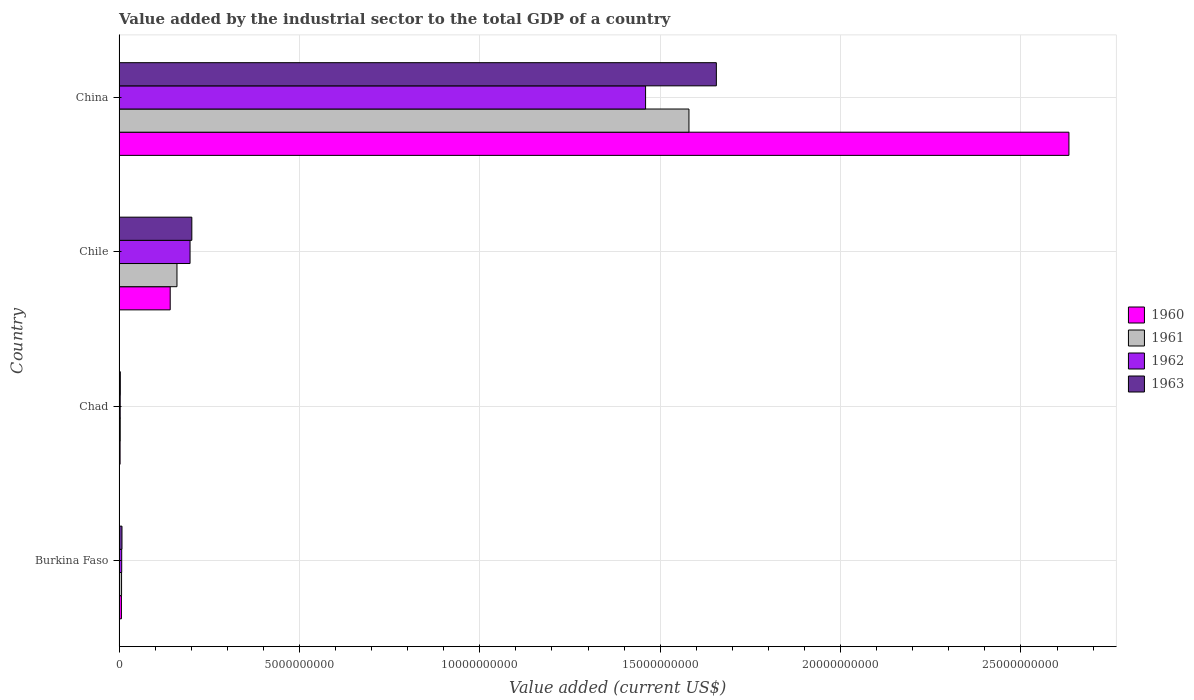How many groups of bars are there?
Your answer should be compact. 4. What is the label of the 3rd group of bars from the top?
Provide a short and direct response. Chad. What is the value added by the industrial sector to the total GDP in 1963 in Burkina Faso?
Keep it short and to the point. 8.13e+07. Across all countries, what is the maximum value added by the industrial sector to the total GDP in 1963?
Your answer should be compact. 1.66e+1. Across all countries, what is the minimum value added by the industrial sector to the total GDP in 1960?
Make the answer very short. 2.88e+07. In which country was the value added by the industrial sector to the total GDP in 1960 minimum?
Make the answer very short. Chad. What is the total value added by the industrial sector to the total GDP in 1961 in the graph?
Offer a very short reply. 1.75e+1. What is the difference between the value added by the industrial sector to the total GDP in 1963 in Chad and that in China?
Provide a short and direct response. -1.65e+1. What is the difference between the value added by the industrial sector to the total GDP in 1961 in Chile and the value added by the industrial sector to the total GDP in 1963 in China?
Your response must be concise. -1.50e+1. What is the average value added by the industrial sector to the total GDP in 1960 per country?
Keep it short and to the point. 6.96e+09. What is the difference between the value added by the industrial sector to the total GDP in 1961 and value added by the industrial sector to the total GDP in 1962 in China?
Provide a succinct answer. 1.20e+09. What is the ratio of the value added by the industrial sector to the total GDP in 1963 in Chile to that in China?
Your answer should be compact. 0.12. Is the value added by the industrial sector to the total GDP in 1960 in Chad less than that in China?
Give a very brief answer. Yes. What is the difference between the highest and the second highest value added by the industrial sector to the total GDP in 1961?
Offer a terse response. 1.42e+1. What is the difference between the highest and the lowest value added by the industrial sector to the total GDP in 1961?
Your response must be concise. 1.58e+1. Is it the case that in every country, the sum of the value added by the industrial sector to the total GDP in 1963 and value added by the industrial sector to the total GDP in 1961 is greater than the sum of value added by the industrial sector to the total GDP in 1960 and value added by the industrial sector to the total GDP in 1962?
Offer a very short reply. No. What does the 1st bar from the bottom in Burkina Faso represents?
Your answer should be compact. 1960. Is it the case that in every country, the sum of the value added by the industrial sector to the total GDP in 1962 and value added by the industrial sector to the total GDP in 1961 is greater than the value added by the industrial sector to the total GDP in 1960?
Offer a very short reply. Yes. How many bars are there?
Make the answer very short. 16. Are all the bars in the graph horizontal?
Provide a succinct answer. Yes. How many countries are there in the graph?
Make the answer very short. 4. What is the difference between two consecutive major ticks on the X-axis?
Your response must be concise. 5.00e+09. Are the values on the major ticks of X-axis written in scientific E-notation?
Offer a very short reply. No. Does the graph contain any zero values?
Your answer should be compact. No. Does the graph contain grids?
Provide a short and direct response. Yes. How many legend labels are there?
Offer a terse response. 4. What is the title of the graph?
Provide a short and direct response. Value added by the industrial sector to the total GDP of a country. What is the label or title of the X-axis?
Make the answer very short. Value added (current US$). What is the label or title of the Y-axis?
Ensure brevity in your answer.  Country. What is the Value added (current US$) of 1960 in Burkina Faso?
Provide a succinct answer. 6.58e+07. What is the Value added (current US$) in 1961 in Burkina Faso?
Your response must be concise. 6.97e+07. What is the Value added (current US$) of 1962 in Burkina Faso?
Your response must be concise. 7.35e+07. What is the Value added (current US$) in 1963 in Burkina Faso?
Provide a succinct answer. 8.13e+07. What is the Value added (current US$) of 1960 in Chad?
Offer a very short reply. 2.88e+07. What is the Value added (current US$) of 1961 in Chad?
Your answer should be compact. 3.27e+07. What is the Value added (current US$) in 1962 in Chad?
Offer a terse response. 3.17e+07. What is the Value added (current US$) in 1963 in Chad?
Your answer should be very brief. 3.49e+07. What is the Value added (current US$) in 1960 in Chile?
Keep it short and to the point. 1.42e+09. What is the Value added (current US$) in 1961 in Chile?
Ensure brevity in your answer.  1.61e+09. What is the Value added (current US$) in 1962 in Chile?
Give a very brief answer. 1.97e+09. What is the Value added (current US$) in 1963 in Chile?
Provide a succinct answer. 2.02e+09. What is the Value added (current US$) of 1960 in China?
Ensure brevity in your answer.  2.63e+1. What is the Value added (current US$) of 1961 in China?
Give a very brief answer. 1.58e+1. What is the Value added (current US$) of 1962 in China?
Ensure brevity in your answer.  1.46e+1. What is the Value added (current US$) of 1963 in China?
Your answer should be compact. 1.66e+1. Across all countries, what is the maximum Value added (current US$) of 1960?
Offer a terse response. 2.63e+1. Across all countries, what is the maximum Value added (current US$) in 1961?
Offer a very short reply. 1.58e+1. Across all countries, what is the maximum Value added (current US$) in 1962?
Give a very brief answer. 1.46e+1. Across all countries, what is the maximum Value added (current US$) of 1963?
Keep it short and to the point. 1.66e+1. Across all countries, what is the minimum Value added (current US$) in 1960?
Offer a terse response. 2.88e+07. Across all countries, what is the minimum Value added (current US$) in 1961?
Ensure brevity in your answer.  3.27e+07. Across all countries, what is the minimum Value added (current US$) of 1962?
Provide a succinct answer. 3.17e+07. Across all countries, what is the minimum Value added (current US$) in 1963?
Make the answer very short. 3.49e+07. What is the total Value added (current US$) in 1960 in the graph?
Offer a very short reply. 2.78e+1. What is the total Value added (current US$) in 1961 in the graph?
Offer a very short reply. 1.75e+1. What is the total Value added (current US$) in 1962 in the graph?
Make the answer very short. 1.67e+1. What is the total Value added (current US$) of 1963 in the graph?
Your answer should be very brief. 1.87e+1. What is the difference between the Value added (current US$) of 1960 in Burkina Faso and that in Chad?
Provide a succinct answer. 3.70e+07. What is the difference between the Value added (current US$) in 1961 in Burkina Faso and that in Chad?
Make the answer very short. 3.70e+07. What is the difference between the Value added (current US$) in 1962 in Burkina Faso and that in Chad?
Give a very brief answer. 4.18e+07. What is the difference between the Value added (current US$) of 1963 in Burkina Faso and that in Chad?
Give a very brief answer. 4.64e+07. What is the difference between the Value added (current US$) of 1960 in Burkina Faso and that in Chile?
Offer a terse response. -1.35e+09. What is the difference between the Value added (current US$) of 1961 in Burkina Faso and that in Chile?
Provide a succinct answer. -1.54e+09. What is the difference between the Value added (current US$) in 1962 in Burkina Faso and that in Chile?
Provide a short and direct response. -1.89e+09. What is the difference between the Value added (current US$) of 1963 in Burkina Faso and that in Chile?
Give a very brief answer. -1.94e+09. What is the difference between the Value added (current US$) of 1960 in Burkina Faso and that in China?
Keep it short and to the point. -2.63e+1. What is the difference between the Value added (current US$) in 1961 in Burkina Faso and that in China?
Your response must be concise. -1.57e+1. What is the difference between the Value added (current US$) of 1962 in Burkina Faso and that in China?
Provide a succinct answer. -1.45e+1. What is the difference between the Value added (current US$) of 1963 in Burkina Faso and that in China?
Keep it short and to the point. -1.65e+1. What is the difference between the Value added (current US$) in 1960 in Chad and that in Chile?
Provide a short and direct response. -1.39e+09. What is the difference between the Value added (current US$) of 1961 in Chad and that in Chile?
Provide a short and direct response. -1.57e+09. What is the difference between the Value added (current US$) of 1962 in Chad and that in Chile?
Keep it short and to the point. -1.94e+09. What is the difference between the Value added (current US$) in 1963 in Chad and that in Chile?
Give a very brief answer. -1.98e+09. What is the difference between the Value added (current US$) in 1960 in Chad and that in China?
Provide a succinct answer. -2.63e+1. What is the difference between the Value added (current US$) of 1961 in Chad and that in China?
Keep it short and to the point. -1.58e+1. What is the difference between the Value added (current US$) in 1962 in Chad and that in China?
Offer a very short reply. -1.46e+1. What is the difference between the Value added (current US$) in 1963 in Chad and that in China?
Keep it short and to the point. -1.65e+1. What is the difference between the Value added (current US$) in 1960 in Chile and that in China?
Your answer should be very brief. -2.49e+1. What is the difference between the Value added (current US$) of 1961 in Chile and that in China?
Give a very brief answer. -1.42e+1. What is the difference between the Value added (current US$) in 1962 in Chile and that in China?
Keep it short and to the point. -1.26e+1. What is the difference between the Value added (current US$) in 1963 in Chile and that in China?
Offer a terse response. -1.45e+1. What is the difference between the Value added (current US$) of 1960 in Burkina Faso and the Value added (current US$) of 1961 in Chad?
Make the answer very short. 3.32e+07. What is the difference between the Value added (current US$) in 1960 in Burkina Faso and the Value added (current US$) in 1962 in Chad?
Ensure brevity in your answer.  3.41e+07. What is the difference between the Value added (current US$) of 1960 in Burkina Faso and the Value added (current US$) of 1963 in Chad?
Your answer should be compact. 3.09e+07. What is the difference between the Value added (current US$) in 1961 in Burkina Faso and the Value added (current US$) in 1962 in Chad?
Provide a succinct answer. 3.79e+07. What is the difference between the Value added (current US$) of 1961 in Burkina Faso and the Value added (current US$) of 1963 in Chad?
Keep it short and to the point. 3.48e+07. What is the difference between the Value added (current US$) of 1962 in Burkina Faso and the Value added (current US$) of 1963 in Chad?
Offer a very short reply. 3.86e+07. What is the difference between the Value added (current US$) of 1960 in Burkina Faso and the Value added (current US$) of 1961 in Chile?
Ensure brevity in your answer.  -1.54e+09. What is the difference between the Value added (current US$) of 1960 in Burkina Faso and the Value added (current US$) of 1962 in Chile?
Make the answer very short. -1.90e+09. What is the difference between the Value added (current US$) of 1960 in Burkina Faso and the Value added (current US$) of 1963 in Chile?
Ensure brevity in your answer.  -1.95e+09. What is the difference between the Value added (current US$) of 1961 in Burkina Faso and the Value added (current US$) of 1962 in Chile?
Ensure brevity in your answer.  -1.90e+09. What is the difference between the Value added (current US$) in 1961 in Burkina Faso and the Value added (current US$) in 1963 in Chile?
Provide a short and direct response. -1.95e+09. What is the difference between the Value added (current US$) of 1962 in Burkina Faso and the Value added (current US$) of 1963 in Chile?
Offer a very short reply. -1.94e+09. What is the difference between the Value added (current US$) of 1960 in Burkina Faso and the Value added (current US$) of 1961 in China?
Provide a succinct answer. -1.57e+1. What is the difference between the Value added (current US$) of 1960 in Burkina Faso and the Value added (current US$) of 1962 in China?
Ensure brevity in your answer.  -1.45e+1. What is the difference between the Value added (current US$) in 1960 in Burkina Faso and the Value added (current US$) in 1963 in China?
Offer a very short reply. -1.65e+1. What is the difference between the Value added (current US$) of 1961 in Burkina Faso and the Value added (current US$) of 1962 in China?
Keep it short and to the point. -1.45e+1. What is the difference between the Value added (current US$) in 1961 in Burkina Faso and the Value added (current US$) in 1963 in China?
Give a very brief answer. -1.65e+1. What is the difference between the Value added (current US$) in 1962 in Burkina Faso and the Value added (current US$) in 1963 in China?
Offer a very short reply. -1.65e+1. What is the difference between the Value added (current US$) of 1960 in Chad and the Value added (current US$) of 1961 in Chile?
Ensure brevity in your answer.  -1.58e+09. What is the difference between the Value added (current US$) in 1960 in Chad and the Value added (current US$) in 1962 in Chile?
Ensure brevity in your answer.  -1.94e+09. What is the difference between the Value added (current US$) in 1960 in Chad and the Value added (current US$) in 1963 in Chile?
Offer a very short reply. -1.99e+09. What is the difference between the Value added (current US$) in 1961 in Chad and the Value added (current US$) in 1962 in Chile?
Offer a terse response. -1.94e+09. What is the difference between the Value added (current US$) of 1961 in Chad and the Value added (current US$) of 1963 in Chile?
Your answer should be very brief. -1.98e+09. What is the difference between the Value added (current US$) of 1962 in Chad and the Value added (current US$) of 1963 in Chile?
Give a very brief answer. -1.99e+09. What is the difference between the Value added (current US$) of 1960 in Chad and the Value added (current US$) of 1961 in China?
Your answer should be very brief. -1.58e+1. What is the difference between the Value added (current US$) in 1960 in Chad and the Value added (current US$) in 1962 in China?
Your response must be concise. -1.46e+1. What is the difference between the Value added (current US$) of 1960 in Chad and the Value added (current US$) of 1963 in China?
Offer a very short reply. -1.65e+1. What is the difference between the Value added (current US$) in 1961 in Chad and the Value added (current US$) in 1962 in China?
Offer a very short reply. -1.46e+1. What is the difference between the Value added (current US$) of 1961 in Chad and the Value added (current US$) of 1963 in China?
Give a very brief answer. -1.65e+1. What is the difference between the Value added (current US$) of 1962 in Chad and the Value added (current US$) of 1963 in China?
Your answer should be compact. -1.65e+1. What is the difference between the Value added (current US$) in 1960 in Chile and the Value added (current US$) in 1961 in China?
Your answer should be compact. -1.44e+1. What is the difference between the Value added (current US$) of 1960 in Chile and the Value added (current US$) of 1962 in China?
Give a very brief answer. -1.32e+1. What is the difference between the Value added (current US$) in 1960 in Chile and the Value added (current US$) in 1963 in China?
Your answer should be compact. -1.51e+1. What is the difference between the Value added (current US$) of 1961 in Chile and the Value added (current US$) of 1962 in China?
Keep it short and to the point. -1.30e+1. What is the difference between the Value added (current US$) in 1961 in Chile and the Value added (current US$) in 1963 in China?
Give a very brief answer. -1.50e+1. What is the difference between the Value added (current US$) in 1962 in Chile and the Value added (current US$) in 1963 in China?
Give a very brief answer. -1.46e+1. What is the average Value added (current US$) of 1960 per country?
Your answer should be compact. 6.96e+09. What is the average Value added (current US$) in 1961 per country?
Provide a short and direct response. 4.38e+09. What is the average Value added (current US$) in 1962 per country?
Your answer should be very brief. 4.17e+09. What is the average Value added (current US$) of 1963 per country?
Offer a very short reply. 4.67e+09. What is the difference between the Value added (current US$) of 1960 and Value added (current US$) of 1961 in Burkina Faso?
Offer a terse response. -3.88e+06. What is the difference between the Value added (current US$) in 1960 and Value added (current US$) in 1962 in Burkina Faso?
Make the answer very short. -7.71e+06. What is the difference between the Value added (current US$) in 1960 and Value added (current US$) in 1963 in Burkina Faso?
Your response must be concise. -1.55e+07. What is the difference between the Value added (current US$) of 1961 and Value added (current US$) of 1962 in Burkina Faso?
Ensure brevity in your answer.  -3.83e+06. What is the difference between the Value added (current US$) of 1961 and Value added (current US$) of 1963 in Burkina Faso?
Make the answer very short. -1.16e+07. What is the difference between the Value added (current US$) of 1962 and Value added (current US$) of 1963 in Burkina Faso?
Provide a succinct answer. -7.75e+06. What is the difference between the Value added (current US$) in 1960 and Value added (current US$) in 1961 in Chad?
Your answer should be very brief. -3.82e+06. What is the difference between the Value added (current US$) in 1960 and Value added (current US$) in 1962 in Chad?
Keep it short and to the point. -2.90e+06. What is the difference between the Value added (current US$) in 1960 and Value added (current US$) in 1963 in Chad?
Provide a short and direct response. -6.04e+06. What is the difference between the Value added (current US$) in 1961 and Value added (current US$) in 1962 in Chad?
Make the answer very short. 9.19e+05. What is the difference between the Value added (current US$) in 1961 and Value added (current US$) in 1963 in Chad?
Offer a very short reply. -2.22e+06. What is the difference between the Value added (current US$) of 1962 and Value added (current US$) of 1963 in Chad?
Keep it short and to the point. -3.14e+06. What is the difference between the Value added (current US$) in 1960 and Value added (current US$) in 1961 in Chile?
Give a very brief answer. -1.88e+08. What is the difference between the Value added (current US$) in 1960 and Value added (current US$) in 1962 in Chile?
Ensure brevity in your answer.  -5.50e+08. What is the difference between the Value added (current US$) of 1960 and Value added (current US$) of 1963 in Chile?
Your answer should be very brief. -5.99e+08. What is the difference between the Value added (current US$) of 1961 and Value added (current US$) of 1962 in Chile?
Give a very brief answer. -3.63e+08. What is the difference between the Value added (current US$) of 1961 and Value added (current US$) of 1963 in Chile?
Offer a terse response. -4.12e+08. What is the difference between the Value added (current US$) in 1962 and Value added (current US$) in 1963 in Chile?
Give a very brief answer. -4.92e+07. What is the difference between the Value added (current US$) in 1960 and Value added (current US$) in 1961 in China?
Provide a short and direct response. 1.05e+1. What is the difference between the Value added (current US$) of 1960 and Value added (current US$) of 1962 in China?
Your response must be concise. 1.17e+1. What is the difference between the Value added (current US$) of 1960 and Value added (current US$) of 1963 in China?
Your response must be concise. 9.77e+09. What is the difference between the Value added (current US$) of 1961 and Value added (current US$) of 1962 in China?
Ensure brevity in your answer.  1.20e+09. What is the difference between the Value added (current US$) of 1961 and Value added (current US$) of 1963 in China?
Your answer should be compact. -7.60e+08. What is the difference between the Value added (current US$) of 1962 and Value added (current US$) of 1963 in China?
Give a very brief answer. -1.96e+09. What is the ratio of the Value added (current US$) in 1960 in Burkina Faso to that in Chad?
Your answer should be compact. 2.28. What is the ratio of the Value added (current US$) in 1961 in Burkina Faso to that in Chad?
Keep it short and to the point. 2.13. What is the ratio of the Value added (current US$) of 1962 in Burkina Faso to that in Chad?
Your answer should be very brief. 2.32. What is the ratio of the Value added (current US$) in 1963 in Burkina Faso to that in Chad?
Keep it short and to the point. 2.33. What is the ratio of the Value added (current US$) of 1960 in Burkina Faso to that in Chile?
Provide a short and direct response. 0.05. What is the ratio of the Value added (current US$) in 1961 in Burkina Faso to that in Chile?
Offer a terse response. 0.04. What is the ratio of the Value added (current US$) in 1962 in Burkina Faso to that in Chile?
Give a very brief answer. 0.04. What is the ratio of the Value added (current US$) in 1963 in Burkina Faso to that in Chile?
Your response must be concise. 0.04. What is the ratio of the Value added (current US$) of 1960 in Burkina Faso to that in China?
Offer a terse response. 0. What is the ratio of the Value added (current US$) in 1961 in Burkina Faso to that in China?
Offer a terse response. 0. What is the ratio of the Value added (current US$) in 1962 in Burkina Faso to that in China?
Offer a terse response. 0.01. What is the ratio of the Value added (current US$) in 1963 in Burkina Faso to that in China?
Keep it short and to the point. 0. What is the ratio of the Value added (current US$) of 1960 in Chad to that in Chile?
Ensure brevity in your answer.  0.02. What is the ratio of the Value added (current US$) of 1961 in Chad to that in Chile?
Your response must be concise. 0.02. What is the ratio of the Value added (current US$) in 1962 in Chad to that in Chile?
Offer a very short reply. 0.02. What is the ratio of the Value added (current US$) in 1963 in Chad to that in Chile?
Provide a short and direct response. 0.02. What is the ratio of the Value added (current US$) of 1960 in Chad to that in China?
Provide a short and direct response. 0. What is the ratio of the Value added (current US$) of 1961 in Chad to that in China?
Keep it short and to the point. 0. What is the ratio of the Value added (current US$) in 1962 in Chad to that in China?
Make the answer very short. 0. What is the ratio of the Value added (current US$) of 1963 in Chad to that in China?
Provide a succinct answer. 0. What is the ratio of the Value added (current US$) in 1960 in Chile to that in China?
Ensure brevity in your answer.  0.05. What is the ratio of the Value added (current US$) of 1961 in Chile to that in China?
Ensure brevity in your answer.  0.1. What is the ratio of the Value added (current US$) in 1962 in Chile to that in China?
Your answer should be compact. 0.13. What is the ratio of the Value added (current US$) of 1963 in Chile to that in China?
Your response must be concise. 0.12. What is the difference between the highest and the second highest Value added (current US$) of 1960?
Your answer should be very brief. 2.49e+1. What is the difference between the highest and the second highest Value added (current US$) in 1961?
Provide a succinct answer. 1.42e+1. What is the difference between the highest and the second highest Value added (current US$) of 1962?
Offer a very short reply. 1.26e+1. What is the difference between the highest and the second highest Value added (current US$) in 1963?
Your answer should be compact. 1.45e+1. What is the difference between the highest and the lowest Value added (current US$) in 1960?
Your answer should be compact. 2.63e+1. What is the difference between the highest and the lowest Value added (current US$) of 1961?
Your answer should be very brief. 1.58e+1. What is the difference between the highest and the lowest Value added (current US$) of 1962?
Provide a short and direct response. 1.46e+1. What is the difference between the highest and the lowest Value added (current US$) in 1963?
Give a very brief answer. 1.65e+1. 